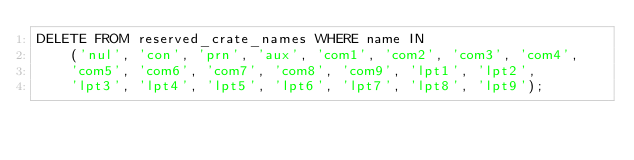Convert code to text. <code><loc_0><loc_0><loc_500><loc_500><_SQL_>DELETE FROM reserved_crate_names WHERE name IN
    ('nul', 'con', 'prn', 'aux', 'com1', 'com2', 'com3', 'com4',
    'com5', 'com6', 'com7', 'com8', 'com9', 'lpt1', 'lpt2',
    'lpt3', 'lpt4', 'lpt5', 'lpt6', 'lpt7', 'lpt8', 'lpt9');
</code> 